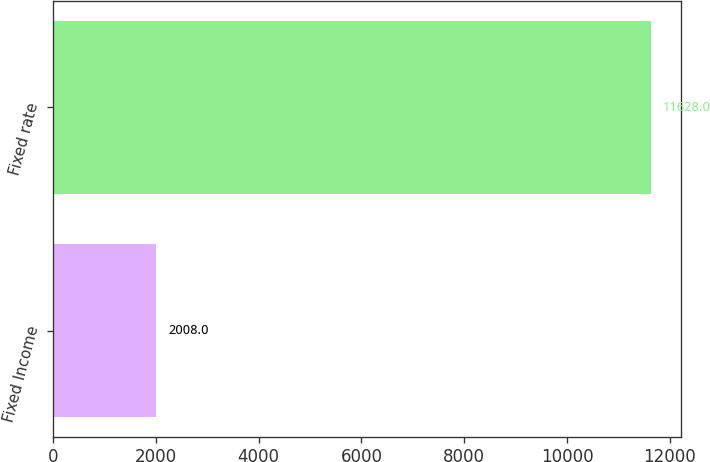Convert chart. <chart><loc_0><loc_0><loc_500><loc_500><bar_chart><fcel>Fixed Income<fcel>Fixed rate<nl><fcel>2008<fcel>11628<nl></chart> 